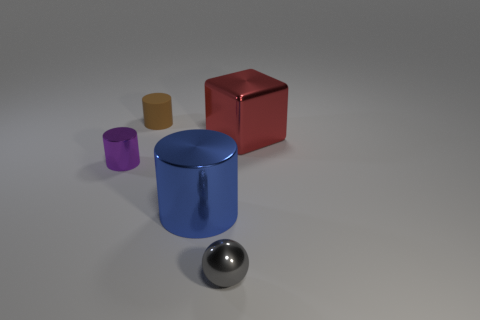Do the thing behind the metal cube and the object in front of the blue metal thing have the same size?
Offer a terse response. Yes. What number of tiny objects are either purple metal cylinders or brown cylinders?
Offer a terse response. 2. What is the material of the big thing on the right side of the big shiny thing that is in front of the small purple thing?
Ensure brevity in your answer.  Metal. Are there any small spheres made of the same material as the purple thing?
Your response must be concise. Yes. Are the gray object and the large object to the right of the tiny gray metallic object made of the same material?
Provide a succinct answer. Yes. What is the color of the sphere that is the same size as the brown cylinder?
Make the answer very short. Gray. What size is the metallic cylinder that is in front of the thing left of the brown matte thing?
Offer a terse response. Large. There is a large metal cylinder; is it the same color as the tiny object that is in front of the large blue metallic cylinder?
Give a very brief answer. No. Is the number of objects on the right side of the brown cylinder less than the number of tiny brown rubber cylinders?
Give a very brief answer. No. What number of other things are the same size as the sphere?
Give a very brief answer. 2. 